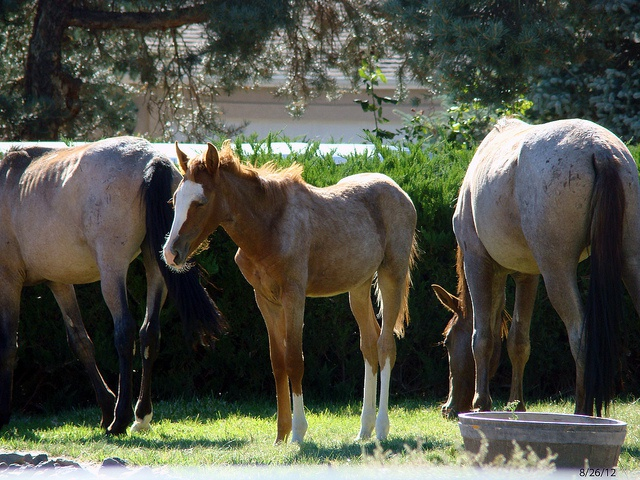Describe the objects in this image and their specific colors. I can see horse in black, gray, and white tones, horse in black, olive, maroon, and gray tones, horse in black and gray tones, and bowl in black, gray, and darkgray tones in this image. 